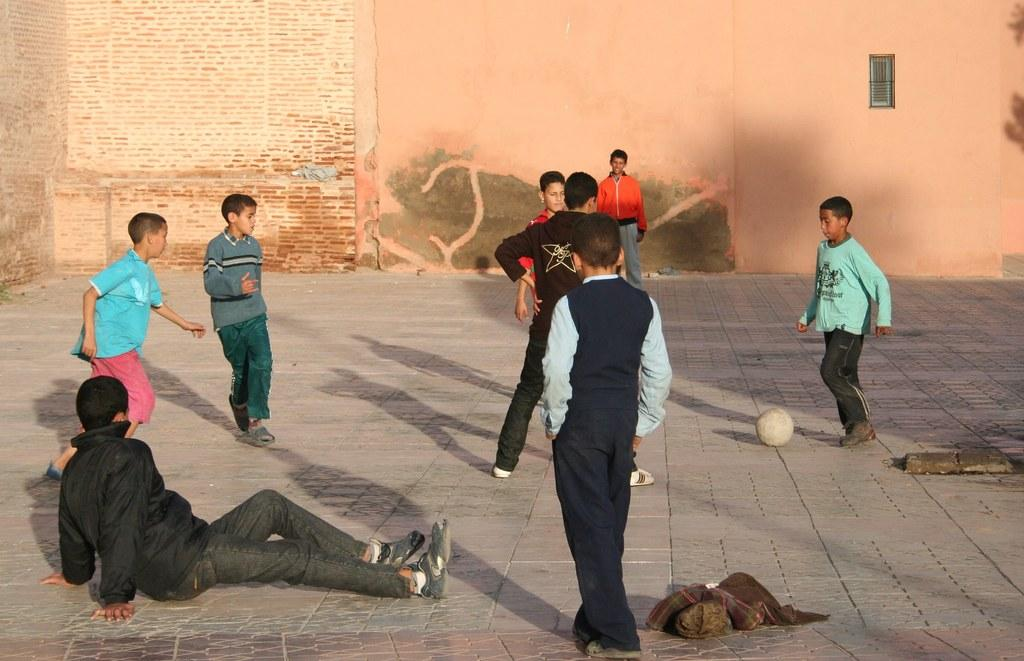What are the kids in the image doing? The kids in the image are playing. What object can be seen in the image that they might be playing with? There is a ball in the image. What can be seen in the background of the image? There is a wall and a window in the background of the image. How many cacti can be seen in the image? There are no cacti present in the image. What type of wool is being used by the kids in the image? There is no wool visible in the image, and the kids are not using any wool in their play. 